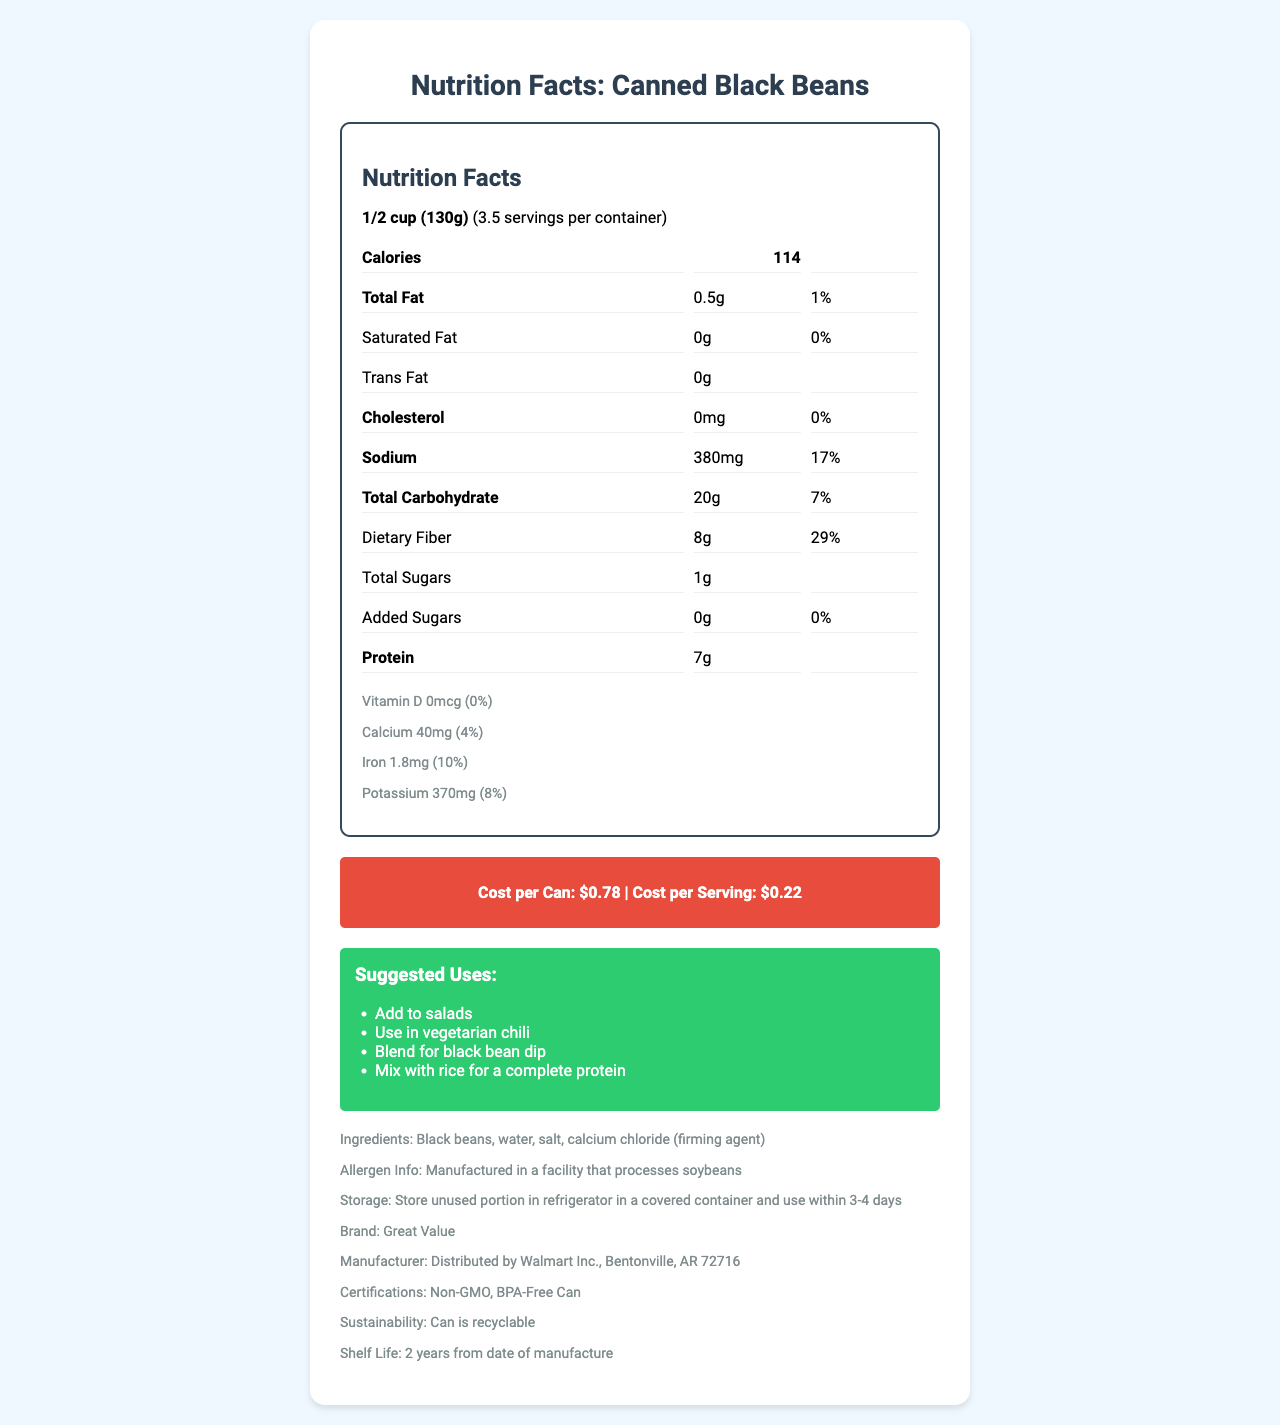what is the serving size of the Canned Black Beans? The serving size is clearly listed as 1/2 cup (130g) in the document.
Answer: 1/2 cup (130g) how many calories are in one serving of the Canned Black Beans? The document states that each serving contains 114 calories.
Answer: 114 what is the total fat content per serving, and what percentage of the daily value does it represent? The total fat content per serving is 0.5g, and it represents 1% of the daily value.
Answer: 0.5g, 1% how much dietary fiber is in each serving? The document shows that each serving contains 8g of dietary fiber.
Answer: 8g what are the suggested uses for this product? The suggested uses listed in the document include adding to salads, using in vegetarian chili, blending for black bean dip, and mixing with rice for a complete protein.
Answer: Add to salads, Use in vegetarian chili, Blend for black bean dip, Mix with rice for a complete protein how much sodium is in one serving of the Canned Black Beans? A. 100mg B. 250mg C. 380mg D. 500mg The document specifies that there are 380mg of sodium per serving.
Answer: C. 380mg what certifications does this product have? A. Organic B. Non-GMO C. Gluten-Free D. Fair Trade The document includes Non-GMO as one of the certifications.
Answer: B. Non-GMO is this product suitable for a person who is allergic to soybeans? The document states that the product is manufactured in a facility that processes soybeans, which could pose a risk for someone with a soybean allergy.
Answer: No what is the cost per can? According to the document, the cost per can is $0.78.
Answer: $0.78 how long is the shelf life of this product? The document indicates that the shelf life is 2 years from the date of manufacture.
Answer: 2 years from date of manufacture what are the main nutrients that make this product nutrient-dense? The main nutrients that contribute to the nutrient density of this product include dietary fiber, protein, iron, folate, magnesium, and phosphorus.
Answer: Dietary fiber, protein, iron, folate, magnesium, phosphorus where is this product manufactured? The document provides distribution information but does not specify the location of manufacturing.
Answer: Not enough information what allergens are processed in the facility where this product is made? The document mentions that the product is manufactured in a facility that processes soybeans.
Answer: Soybeans summarize the nutritional benefits of Canned Black Beans mentioned in the document. The Canned Black Beans' nutritional benefits include high dietary fiber and protein content, essential minerals like iron, folate, magnesium, phosphorus, and low levels of total fat and sodium. It is also certified Non-GMO, packaged in BPA-Free cans, and has suggested versatile uses like adding to salads, vegetarian chili, black bean dip, and mixing with rice.
Answer: Canned Black Beans are a low-cost, nutrient-dense food item that provides significant dietary fiber, protein, iron, and other essential minerals. It has low total fat, no cholesterol, and negligible sugars, making it a healthy addition to various meals. The product is also Non-GMO and packed in a BPA-Free can with sustainability in mind. what is the percentage daily value of saturated fat in one serving? According to the document, the saturated fat content per serving is 0g, which is 0% of the daily value.
Answer: 0% describe the storage instructions for the unused portion of this product. The document states that the unused portion should be stored in a refrigerator in a covered container and used within 3-4 days.
Answer: Store unused portion in refrigerator in a covered container and use within 3-4 days 